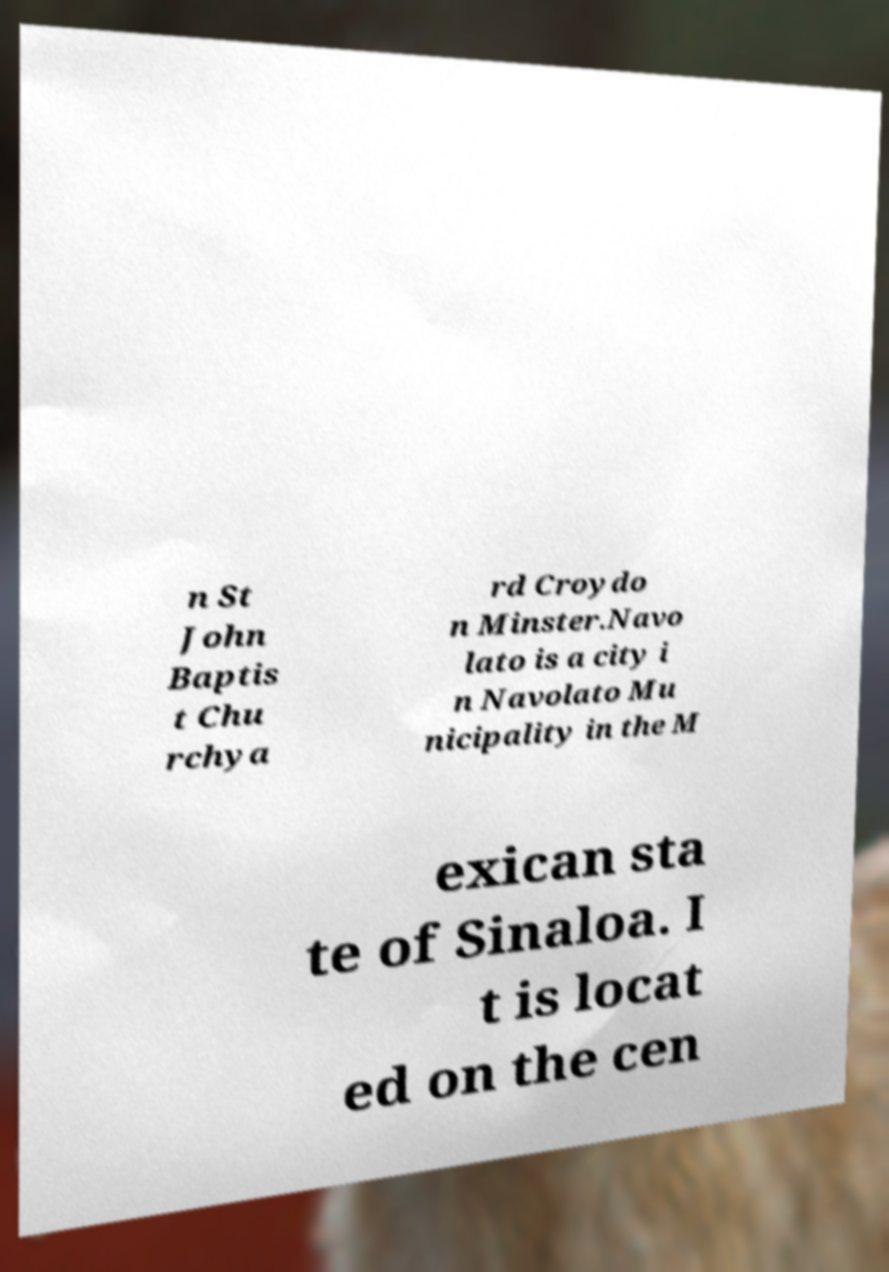Can you accurately transcribe the text from the provided image for me? n St John Baptis t Chu rchya rd Croydo n Minster.Navo lato is a city i n Navolato Mu nicipality in the M exican sta te of Sinaloa. I t is locat ed on the cen 